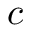Convert formula to latex. <formula><loc_0><loc_0><loc_500><loc_500>c</formula> 